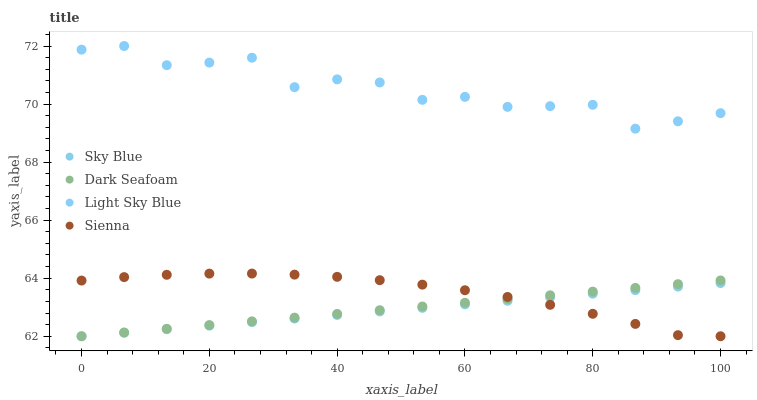Does Sky Blue have the minimum area under the curve?
Answer yes or no. Yes. Does Light Sky Blue have the maximum area under the curve?
Answer yes or no. Yes. Does Dark Seafoam have the minimum area under the curve?
Answer yes or no. No. Does Dark Seafoam have the maximum area under the curve?
Answer yes or no. No. Is Dark Seafoam the smoothest?
Answer yes or no. Yes. Is Light Sky Blue the roughest?
Answer yes or no. Yes. Is Sky Blue the smoothest?
Answer yes or no. No. Is Sky Blue the roughest?
Answer yes or no. No. Does Sienna have the lowest value?
Answer yes or no. Yes. Does Light Sky Blue have the lowest value?
Answer yes or no. No. Does Light Sky Blue have the highest value?
Answer yes or no. Yes. Does Dark Seafoam have the highest value?
Answer yes or no. No. Is Dark Seafoam less than Light Sky Blue?
Answer yes or no. Yes. Is Light Sky Blue greater than Sky Blue?
Answer yes or no. Yes. Does Sienna intersect Sky Blue?
Answer yes or no. Yes. Is Sienna less than Sky Blue?
Answer yes or no. No. Is Sienna greater than Sky Blue?
Answer yes or no. No. Does Dark Seafoam intersect Light Sky Blue?
Answer yes or no. No. 